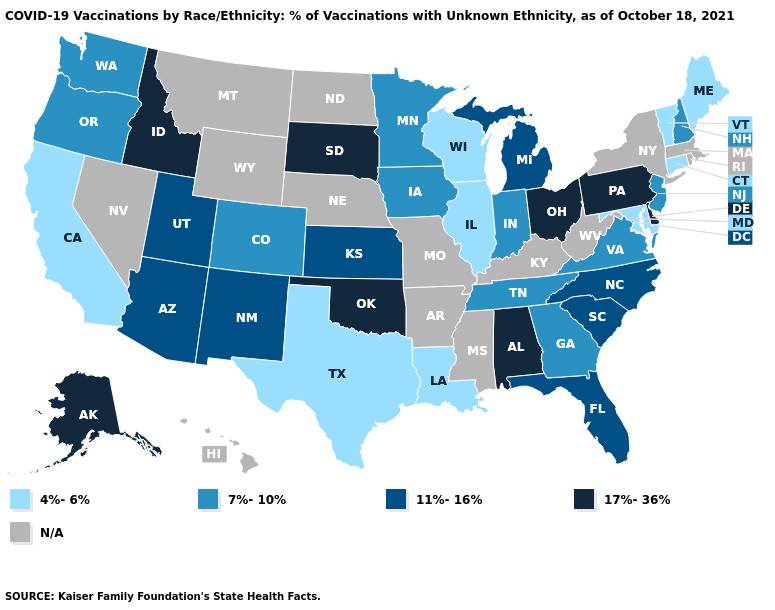Does Delaware have the highest value in the USA?
Short answer required. Yes. How many symbols are there in the legend?
Write a very short answer. 5. Name the states that have a value in the range 17%-36%?
Answer briefly. Alabama, Alaska, Delaware, Idaho, Ohio, Oklahoma, Pennsylvania, South Dakota. Is the legend a continuous bar?
Give a very brief answer. No. Name the states that have a value in the range N/A?
Give a very brief answer. Arkansas, Hawaii, Kentucky, Massachusetts, Mississippi, Missouri, Montana, Nebraska, Nevada, New York, North Dakota, Rhode Island, West Virginia, Wyoming. Name the states that have a value in the range 17%-36%?
Keep it brief. Alabama, Alaska, Delaware, Idaho, Ohio, Oklahoma, Pennsylvania, South Dakota. How many symbols are there in the legend?
Answer briefly. 5. Name the states that have a value in the range 11%-16%?
Keep it brief. Arizona, Florida, Kansas, Michigan, New Mexico, North Carolina, South Carolina, Utah. Among the states that border Kansas , does Colorado have the highest value?
Short answer required. No. Among the states that border Pennsylvania , which have the highest value?
Keep it brief. Delaware, Ohio. What is the value of Hawaii?
Short answer required. N/A. Among the states that border Iowa , which have the lowest value?
Write a very short answer. Illinois, Wisconsin. Name the states that have a value in the range 4%-6%?
Give a very brief answer. California, Connecticut, Illinois, Louisiana, Maine, Maryland, Texas, Vermont, Wisconsin. Name the states that have a value in the range 11%-16%?
Be succinct. Arizona, Florida, Kansas, Michigan, New Mexico, North Carolina, South Carolina, Utah. 